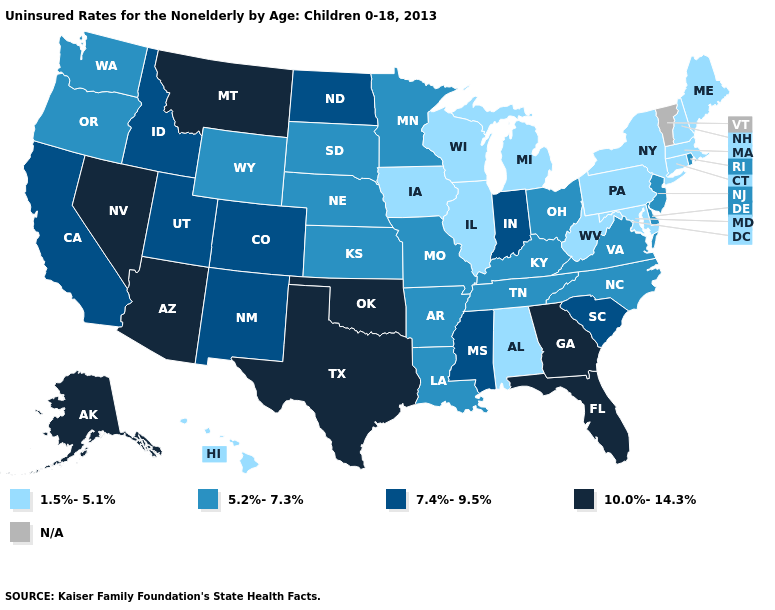Among the states that border Texas , does Arkansas have the lowest value?
Concise answer only. Yes. Which states hav the highest value in the West?
Be succinct. Alaska, Arizona, Montana, Nevada. Does Ohio have the highest value in the USA?
Give a very brief answer. No. What is the value of Kansas?
Write a very short answer. 5.2%-7.3%. Name the states that have a value in the range 1.5%-5.1%?
Quick response, please. Alabama, Connecticut, Hawaii, Illinois, Iowa, Maine, Maryland, Massachusetts, Michigan, New Hampshire, New York, Pennsylvania, West Virginia, Wisconsin. What is the value of New Mexico?
Concise answer only. 7.4%-9.5%. Does Arizona have the highest value in the USA?
Be succinct. Yes. What is the lowest value in states that border Arkansas?
Be succinct. 5.2%-7.3%. How many symbols are there in the legend?
Keep it brief. 5. Among the states that border New Mexico , which have the lowest value?
Answer briefly. Colorado, Utah. What is the value of Mississippi?
Short answer required. 7.4%-9.5%. Among the states that border Michigan , does Indiana have the highest value?
Answer briefly. Yes. Name the states that have a value in the range 5.2%-7.3%?
Write a very short answer. Arkansas, Delaware, Kansas, Kentucky, Louisiana, Minnesota, Missouri, Nebraska, New Jersey, North Carolina, Ohio, Oregon, Rhode Island, South Dakota, Tennessee, Virginia, Washington, Wyoming. 